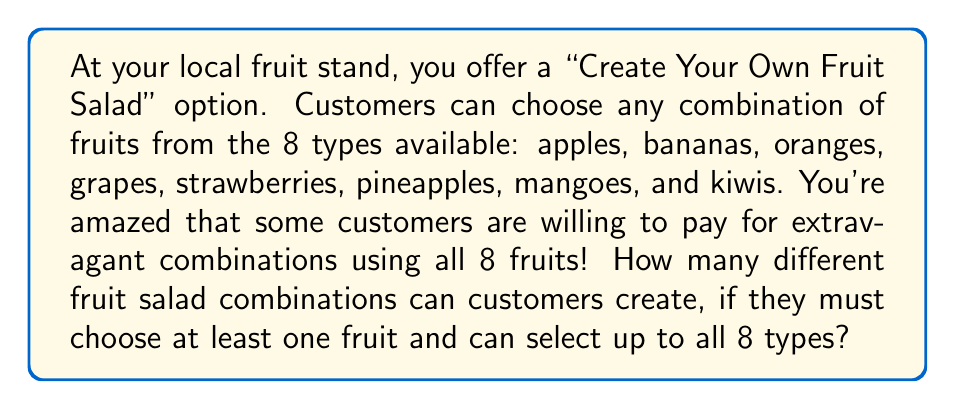Can you answer this question? To solve this problem, we need to use the concept of combinations with repetition allowed.

1) First, let's consider why this is a combination problem and not a permutation problem:
   - The order of selection doesn't matter (e.g., choosing apple then banana is the same as banana then apple).
   - Each fruit can be either selected or not selected.

2) For each fruit, we have two choices: include it or not include it.

3) The total number of combinations is equal to all possible ways to make these choices for all 8 fruits, minus one (because we can't have a salad with no fruits).

4) This scenario is equivalent to finding the number of subsets of a set with 8 elements, excluding the empty set.

5) The formula for the number of subsets of a set with $n$ elements is $2^n$.

6) In this case, $n = 8$ (number of fruit types).

7) Therefore, the total number of combinations is:

   $$ \text{Total combinations} = 2^8 - 1 = 256 - 1 = 255 $$

The subtraction of 1 is to exclude the empty set (the case where no fruit is chosen).
Answer: 255 different fruit salad combinations 